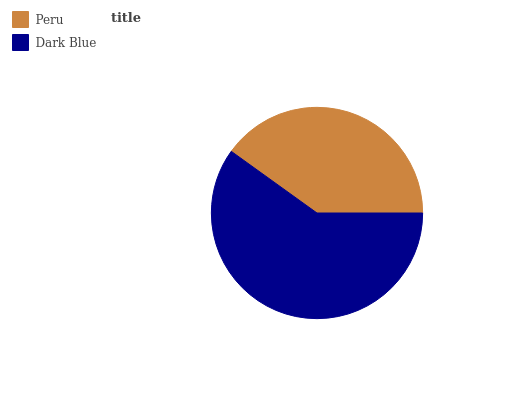Is Peru the minimum?
Answer yes or no. Yes. Is Dark Blue the maximum?
Answer yes or no. Yes. Is Dark Blue the minimum?
Answer yes or no. No. Is Dark Blue greater than Peru?
Answer yes or no. Yes. Is Peru less than Dark Blue?
Answer yes or no. Yes. Is Peru greater than Dark Blue?
Answer yes or no. No. Is Dark Blue less than Peru?
Answer yes or no. No. Is Dark Blue the high median?
Answer yes or no. Yes. Is Peru the low median?
Answer yes or no. Yes. Is Peru the high median?
Answer yes or no. No. Is Dark Blue the low median?
Answer yes or no. No. 